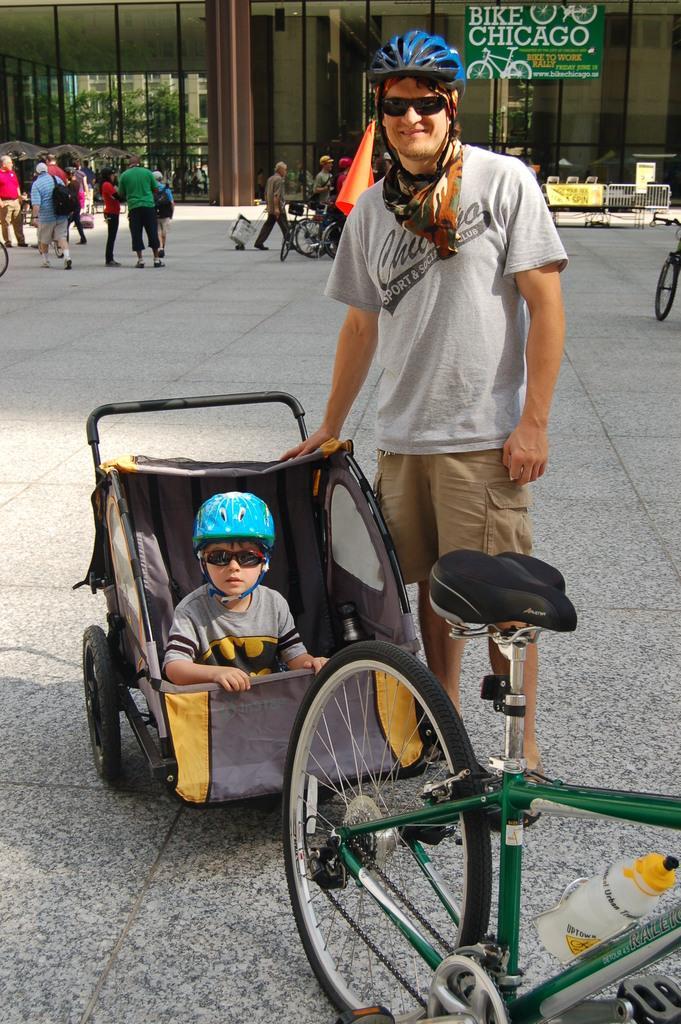How would you summarize this image in a sentence or two? This image consists of many persons. In the front, we can see a man standing a wearing a blue helmet. Beside him, there is a kid sitting in a trolley. At the bottom, there is a road. In the background, there is a building. 